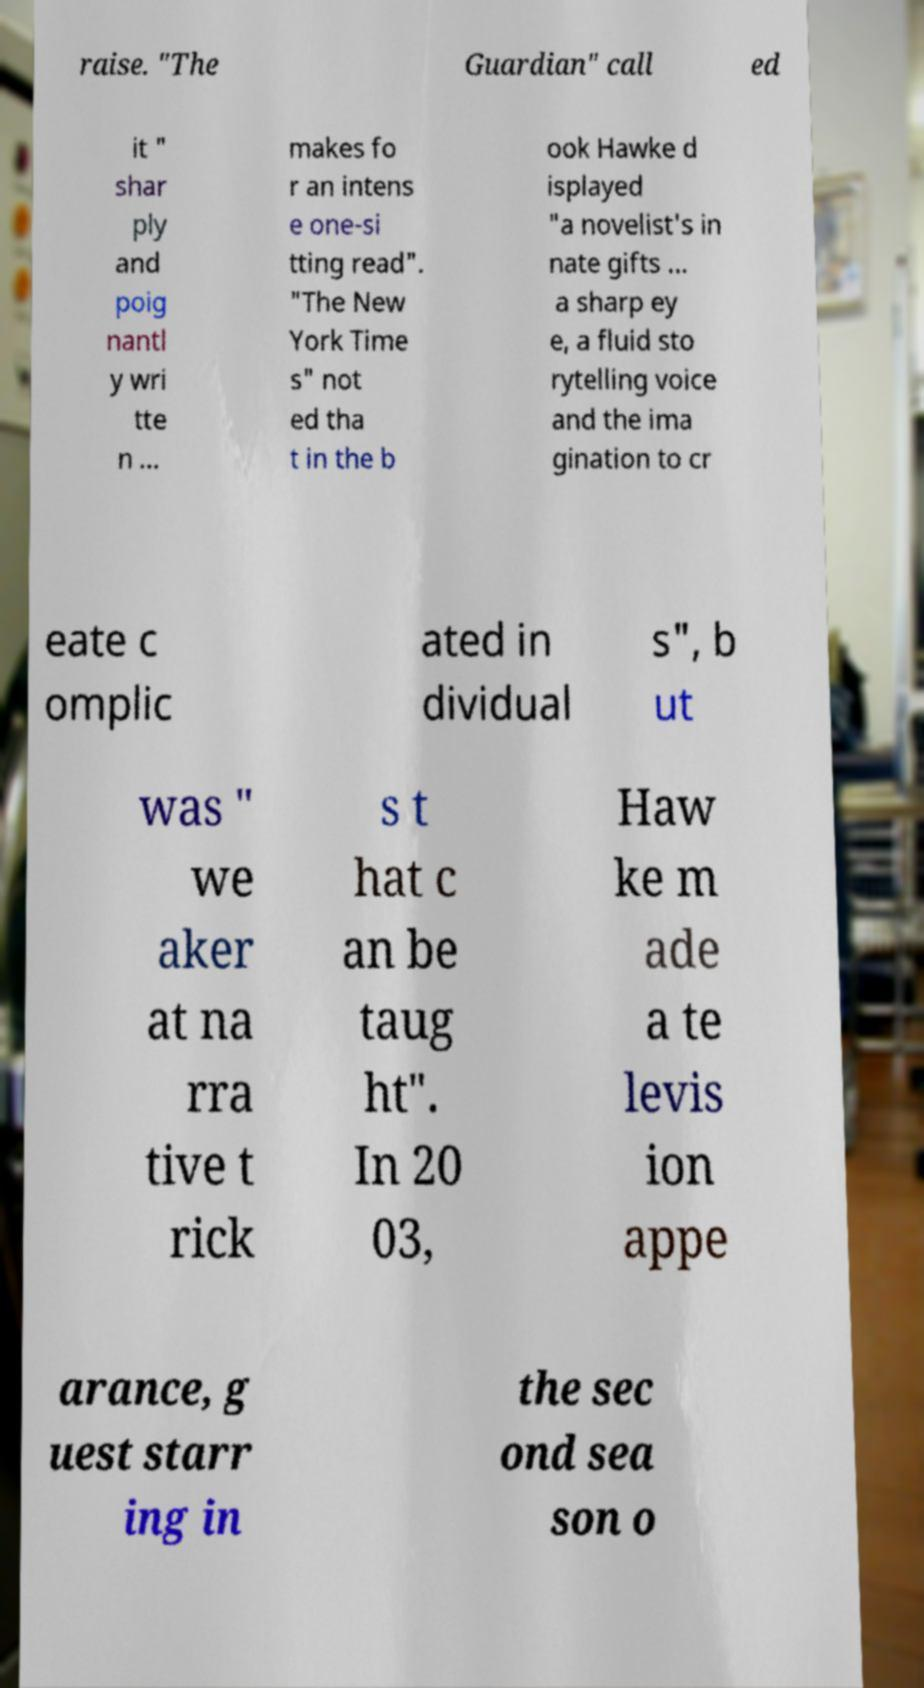Please read and relay the text visible in this image. What does it say? raise. "The Guardian" call ed it " shar ply and poig nantl y wri tte n ... makes fo r an intens e one-si tting read". "The New York Time s" not ed tha t in the b ook Hawke d isplayed "a novelist's in nate gifts ... a sharp ey e, a fluid sto rytelling voice and the ima gination to cr eate c omplic ated in dividual s", b ut was " we aker at na rra tive t rick s t hat c an be taug ht". In 20 03, Haw ke m ade a te levis ion appe arance, g uest starr ing in the sec ond sea son o 